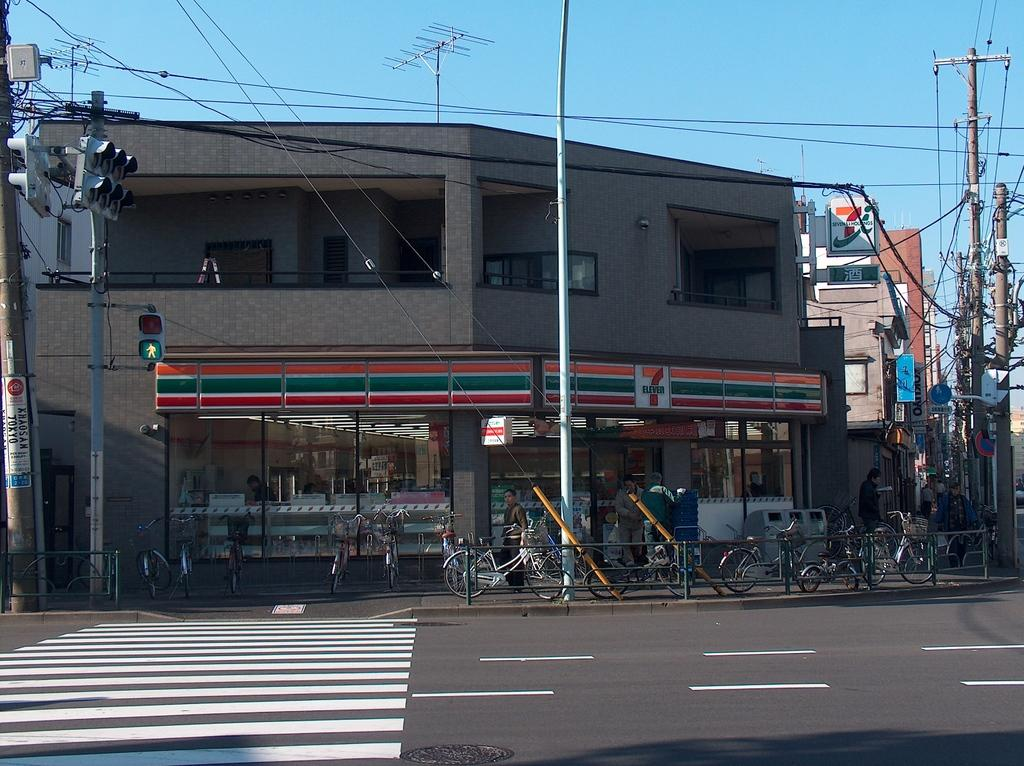Provide a one-sentence caption for the provided image. Many bikes are sitting in front of a 7-Eleven. 